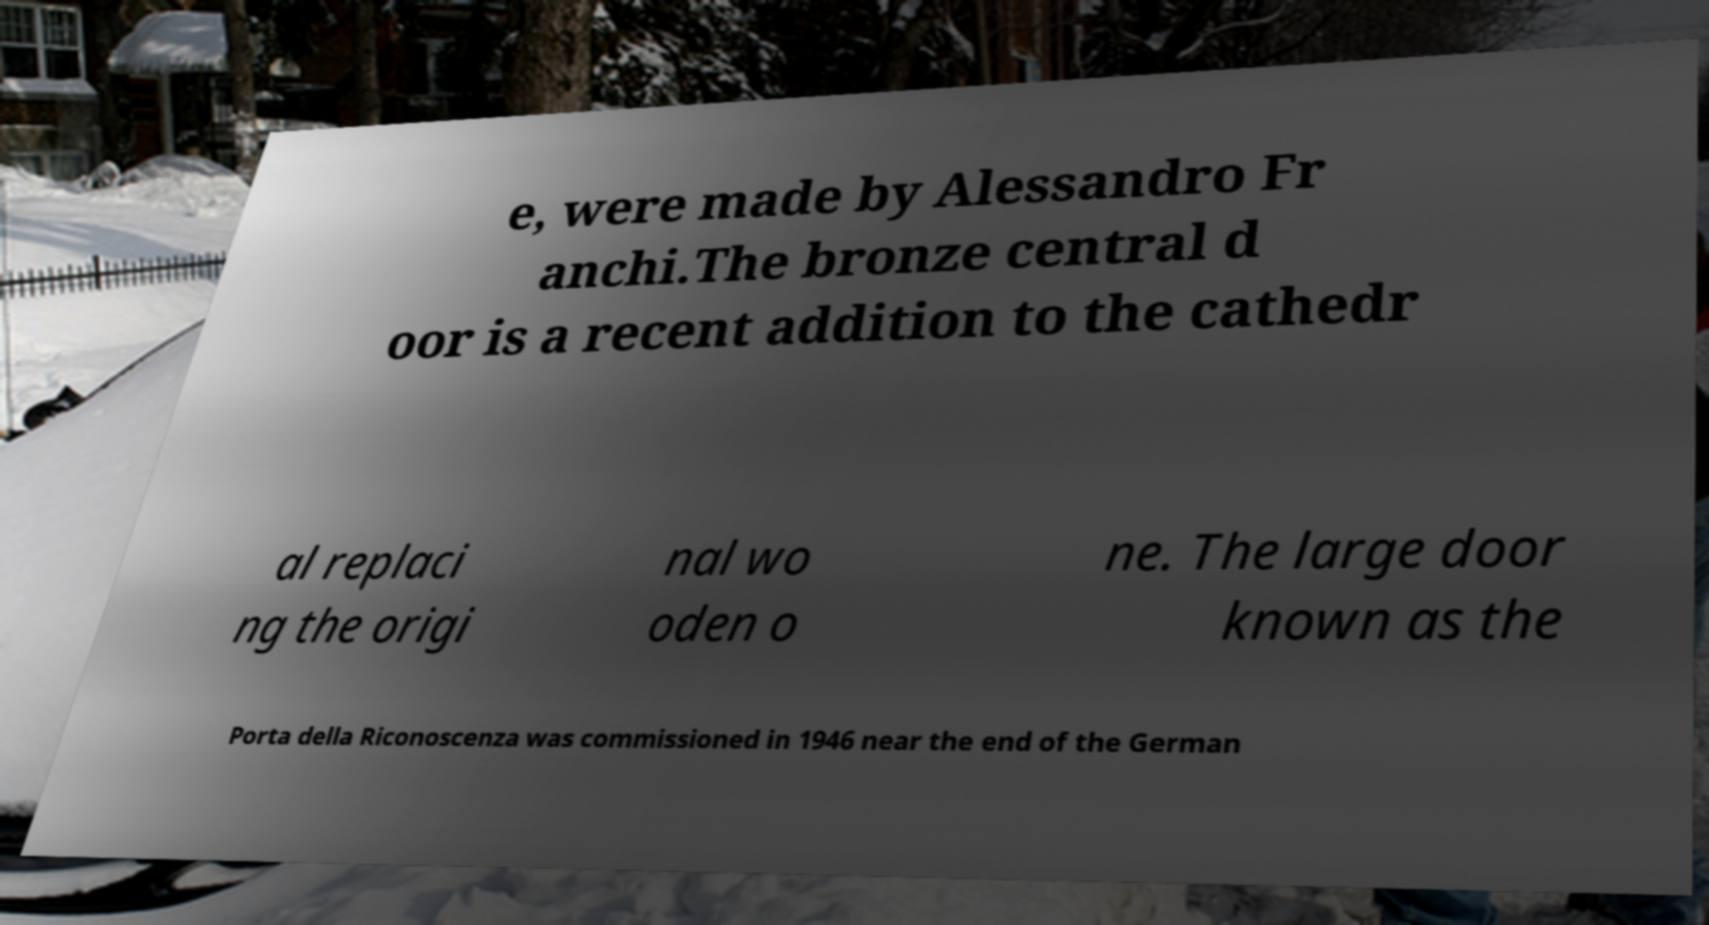What messages or text are displayed in this image? I need them in a readable, typed format. e, were made by Alessandro Fr anchi.The bronze central d oor is a recent addition to the cathedr al replaci ng the origi nal wo oden o ne. The large door known as the Porta della Riconoscenza was commissioned in 1946 near the end of the German 